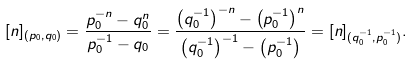<formula> <loc_0><loc_0><loc_500><loc_500>[ n ] _ { ( p _ { 0 } , q _ { 0 } ) } = \frac { p ^ { - n } _ { 0 } - q ^ { n } _ { 0 } } { p ^ { - 1 } _ { 0 } - q _ { 0 } } = \frac { \left ( q ^ { - 1 } _ { 0 } \right ) ^ { - n } - \left ( p ^ { - 1 } _ { 0 } \right ) ^ { n } } { \left ( q ^ { - 1 } _ { 0 } \right ) ^ { - 1 } - \left ( p ^ { - 1 } _ { 0 } \right ) } = [ n ] _ { ( q ^ { - 1 } _ { 0 } , p ^ { - 1 } _ { 0 } ) } .</formula> 